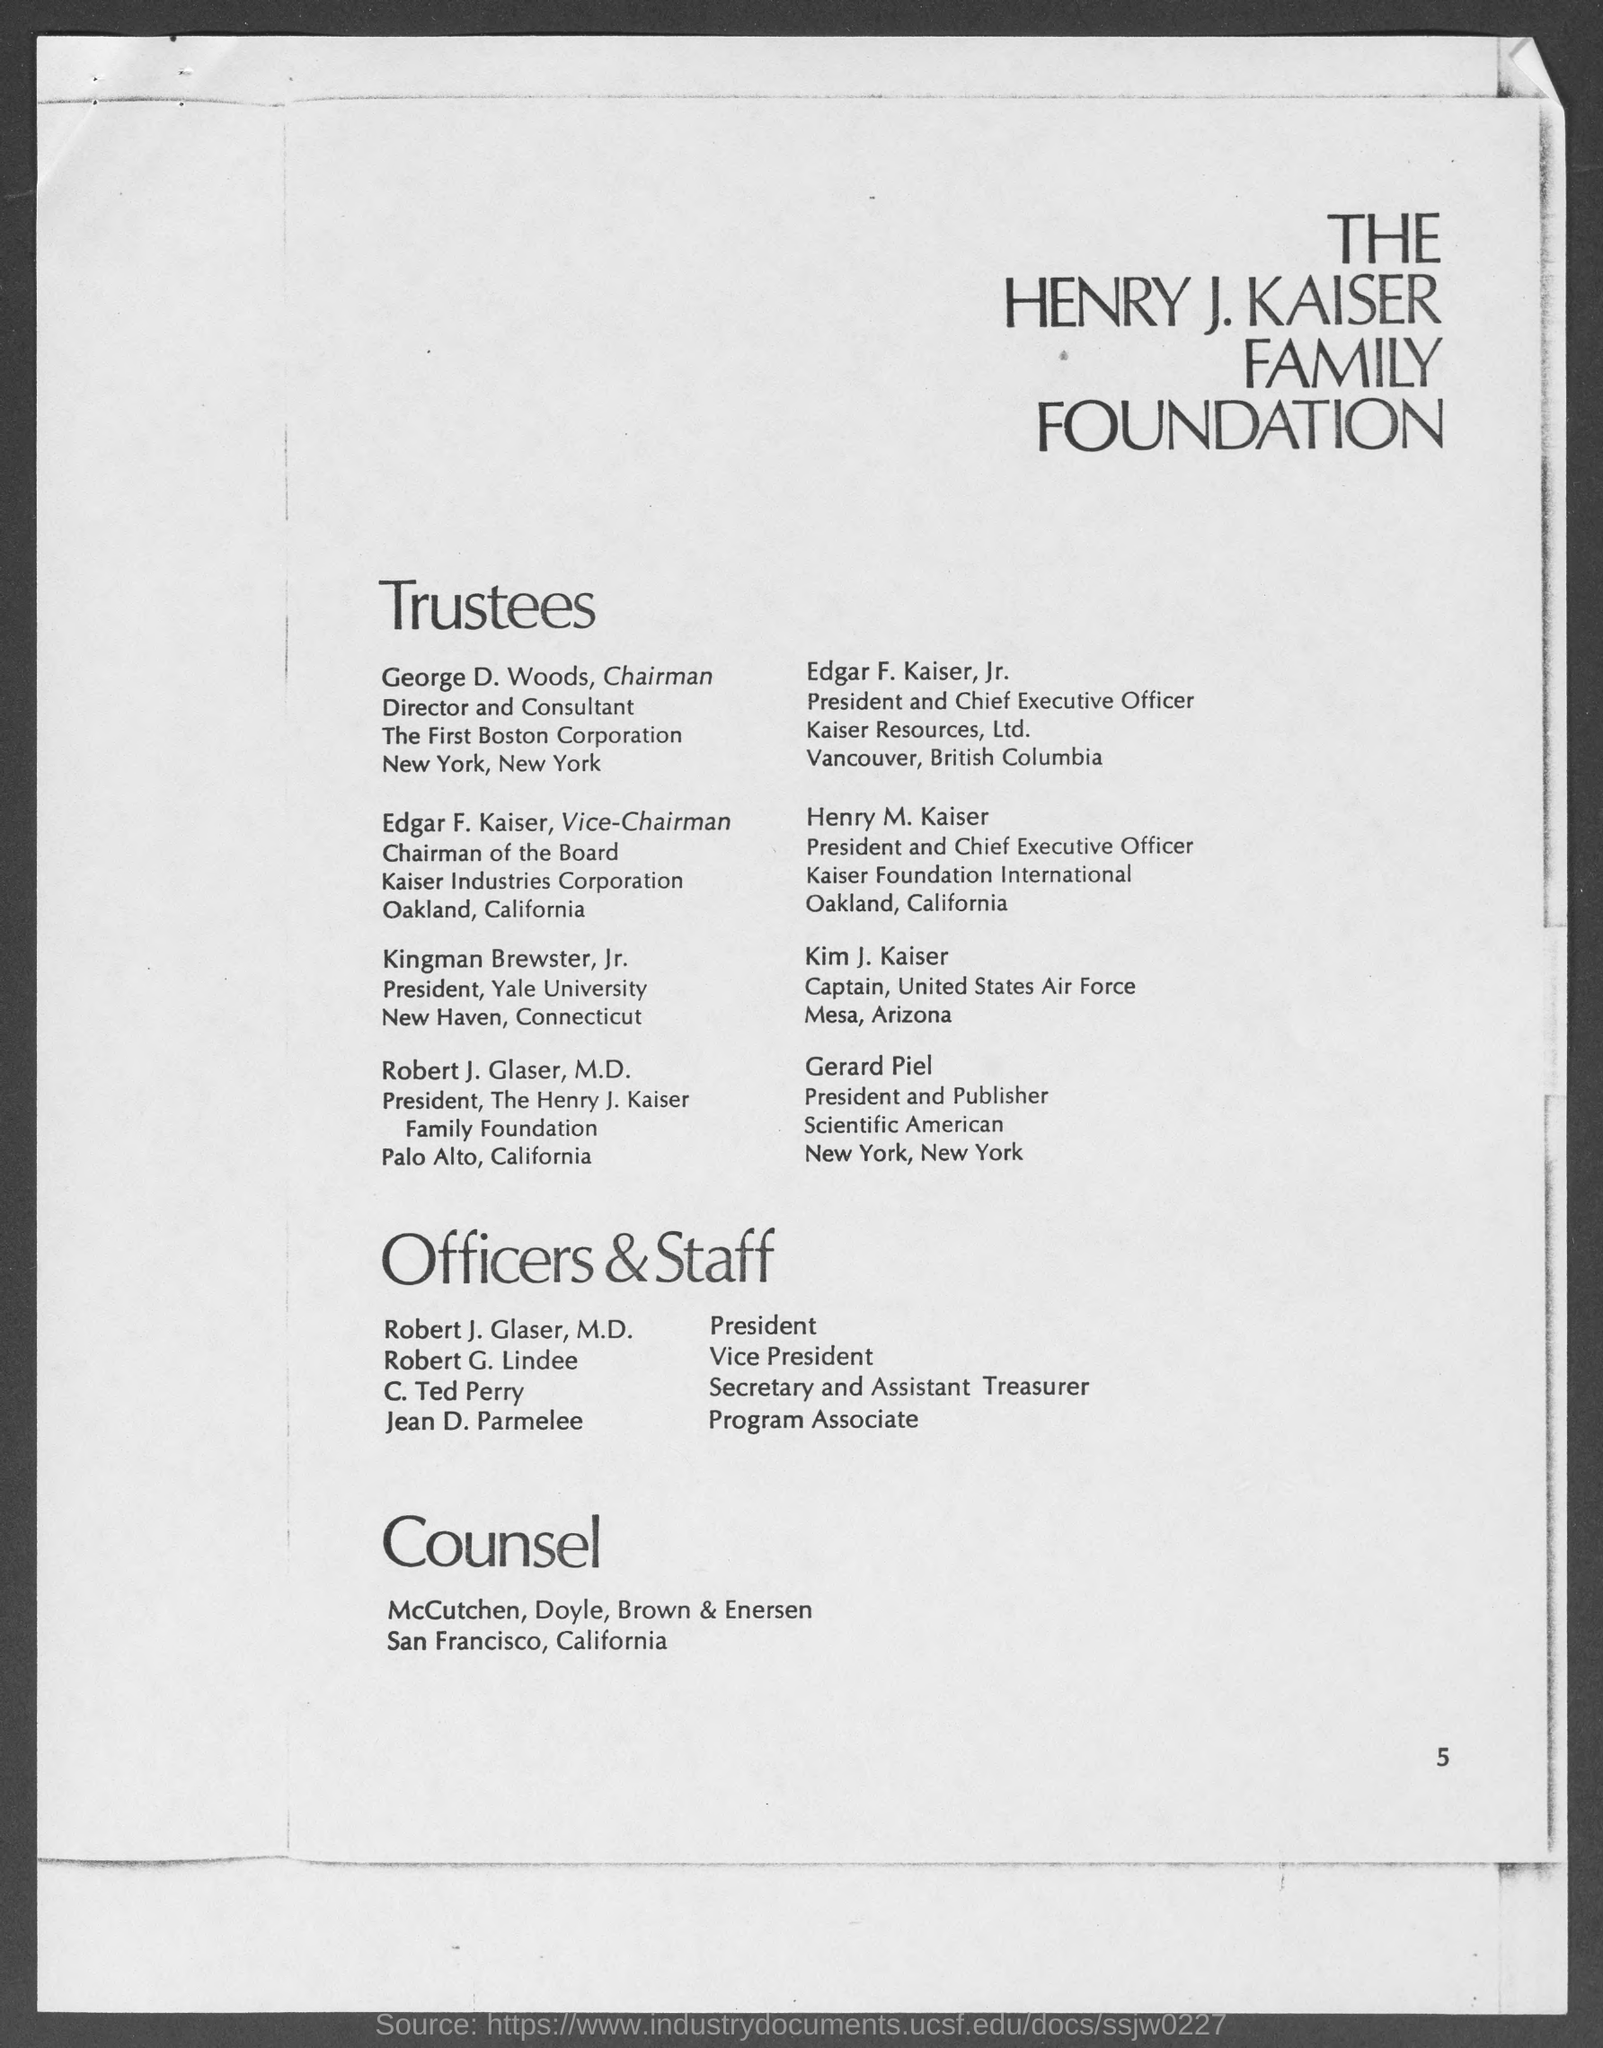What is the name of the family foundation ?
Your answer should be very brief. The Henry J. Kaiser Family Foundation. What is the page number at bottom of the page ?
Give a very brief answer. 5. Who is the president and publisher, scientific american ?
Provide a short and direct response. Gerard Piel. Who is the captain, united states air force?
Your response must be concise. Kim J. Kaiser. Who is the president and chief executive officer, kaiser foundation international ?
Make the answer very short. Henry M. Kaiser. Who is the president and chief executive officer of kaiser resources, ltd. ?
Provide a short and direct response. Edgar F. Kaiser, Jr. Who is the president, the henry j. kaiser family foundation ?
Your response must be concise. Robert J. Glaser, M.D. Who is the president, yale university ?
Make the answer very short. Kingman Brewster, Jr. 